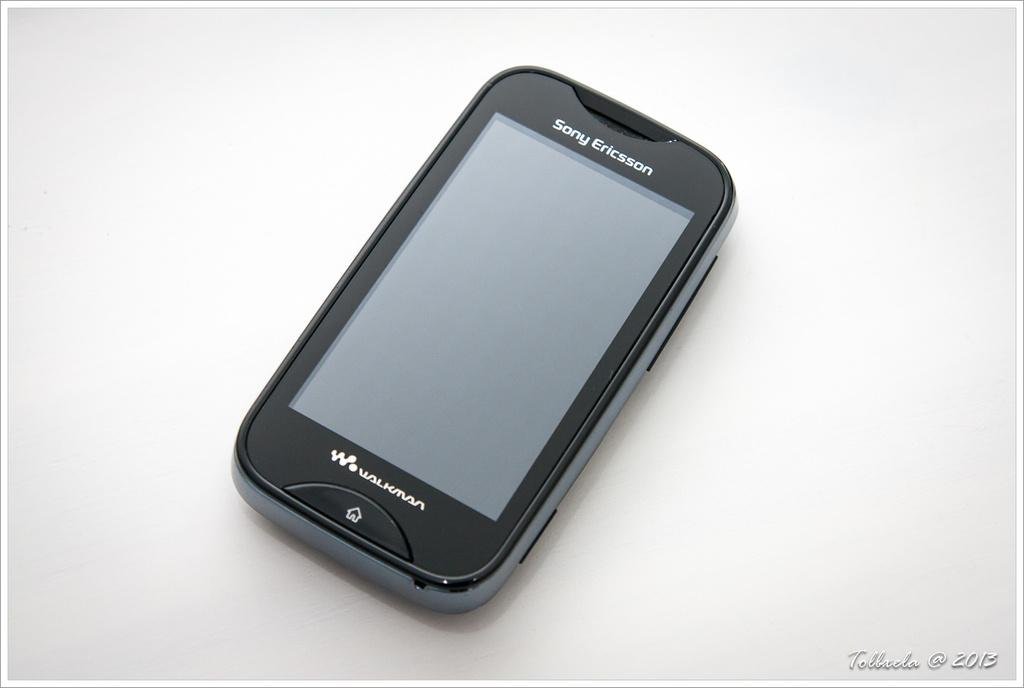Provide a one-sentence caption for the provided image. A black Sony Ericson Walkman portable music player with Tollada@2013 in the bottom right corner. 